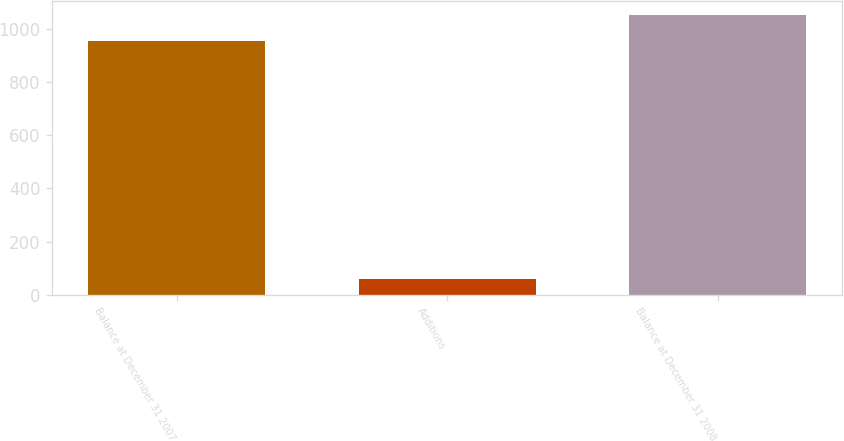<chart> <loc_0><loc_0><loc_500><loc_500><bar_chart><fcel>Balance at December 31 2007<fcel>Additions<fcel>Balance at December 31 2008<nl><fcel>957<fcel>58<fcel>1052.7<nl></chart> 